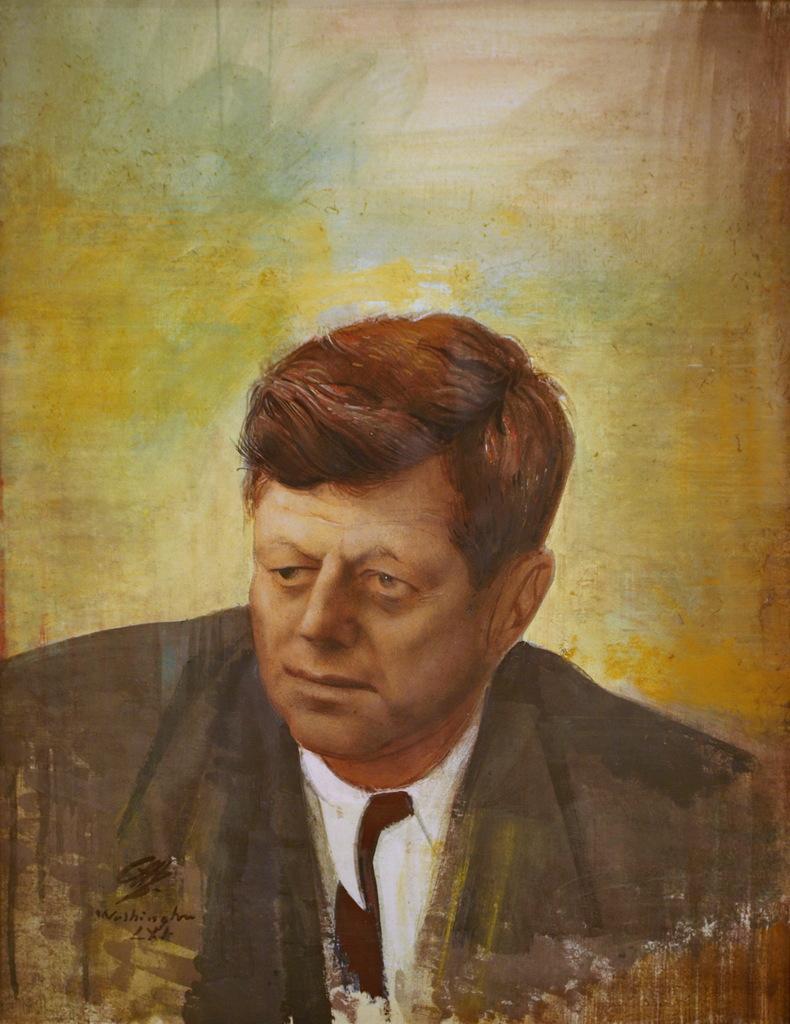In one or two sentences, can you explain what this image depicts? In this image I can see a painting of a man and there is a signature. 